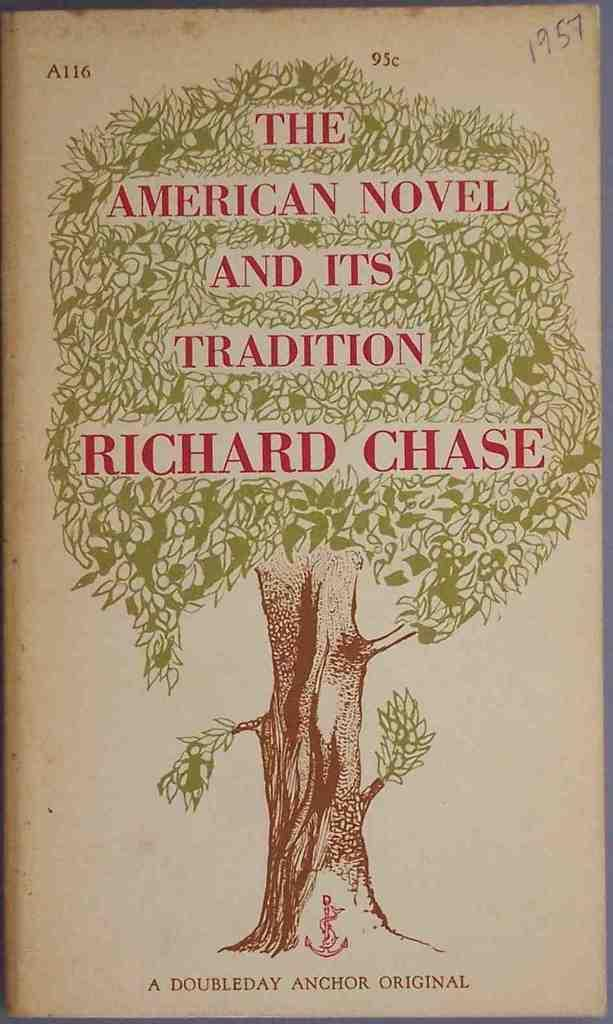<image>
Share a concise interpretation of the image provided. The cover of The American Novel and its Tradition by Richard Chase. 